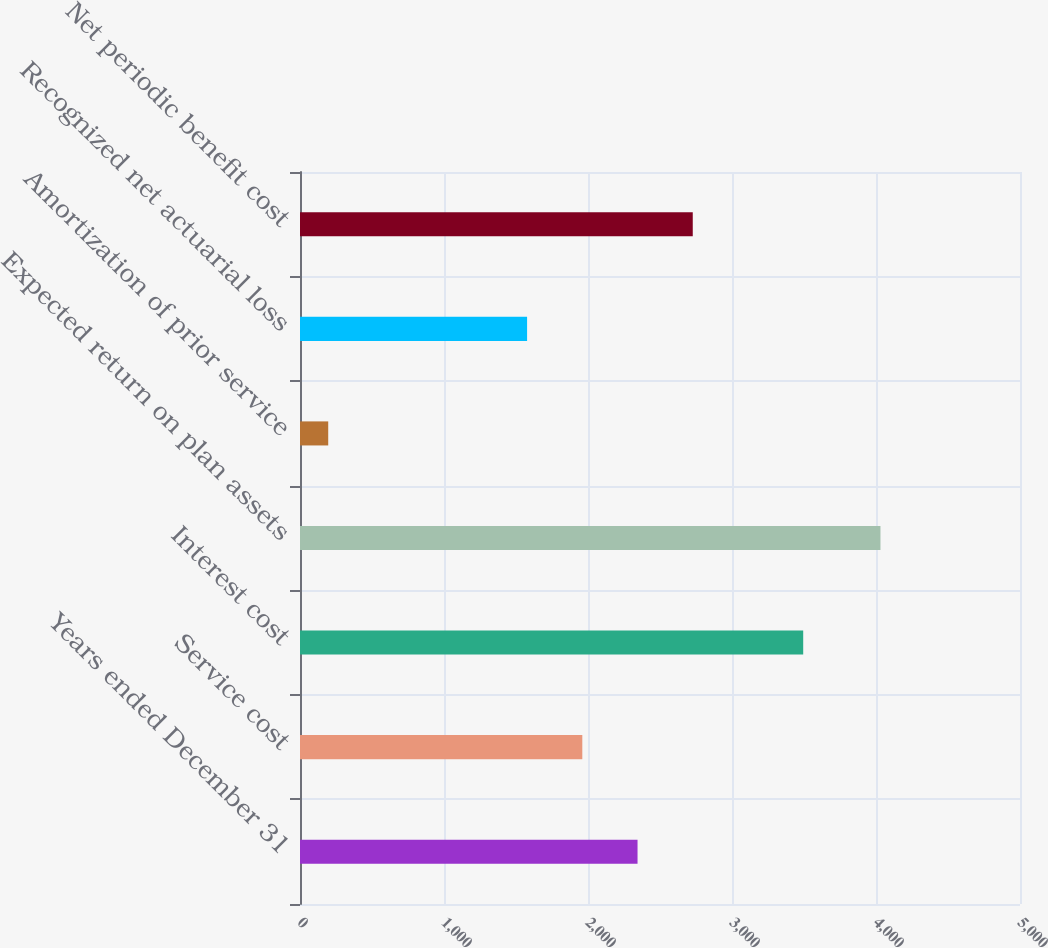<chart> <loc_0><loc_0><loc_500><loc_500><bar_chart><fcel>Years ended December 31<fcel>Service cost<fcel>Interest cost<fcel>Expected return on plan assets<fcel>Amortization of prior service<fcel>Recognized net actuarial loss<fcel>Net periodic benefit cost<nl><fcel>2344<fcel>1960.5<fcel>3494.5<fcel>4031<fcel>196<fcel>1577<fcel>2727.5<nl></chart> 